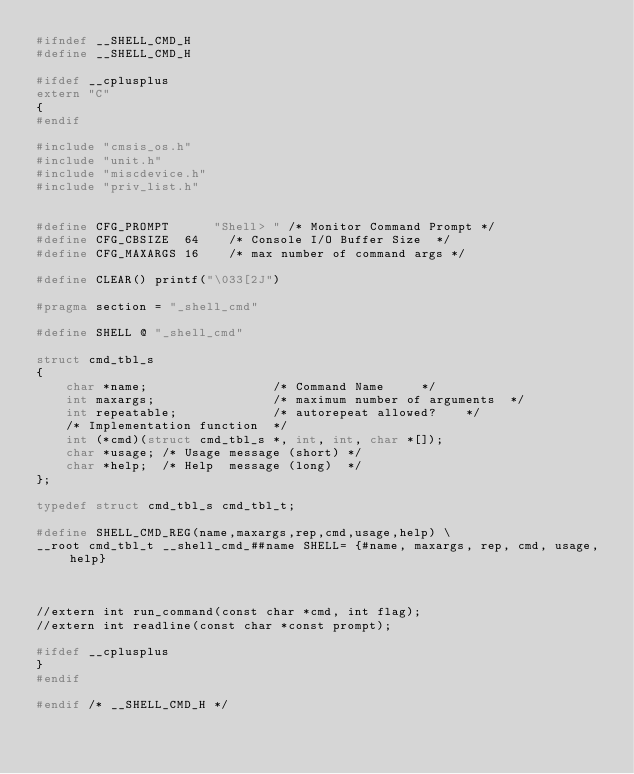Convert code to text. <code><loc_0><loc_0><loc_500><loc_500><_C_>#ifndef __SHELL_CMD_H
#define __SHELL_CMD_H

#ifdef __cplusplus
extern "C"
{
#endif

#include "cmsis_os.h"
#include "unit.h"
#include "miscdevice.h"
#include "priv_list.h"


#define	CFG_PROMPT			"Shell> "	/* Monitor Command Prompt	*/
#define CFG_CBSIZE	64		/* Console I/O Buffer Size	*/
#define	CFG_MAXARGS	16		/* max number of command args	*/

#define CLEAR() printf("\033[2J") 
  
#pragma section = "_shell_cmd"

#define SHELL @ "_shell_cmd"

struct cmd_tbl_s
{
    char *name;                 /* Command Name			*/
    int maxargs;                /* maximum number of arguments	*/
    int repeatable;             /* autorepeat allowed?		*/
    /* Implementation function	*/
    int (*cmd)(struct cmd_tbl_s *, int, int, char *[]);
    char *usage; /* Usage message	(short)	*/
    char *help;  /* Help  message	(long)	*/
};

typedef struct cmd_tbl_s cmd_tbl_t;

#define SHELL_CMD_REG(name,maxargs,rep,cmd,usage,help) \
__root cmd_tbl_t __shell_cmd_##name SHELL= {#name, maxargs, rep, cmd, usage, help}



//extern int run_command(const char *cmd, int flag);
//extern int readline(const char *const prompt);

#ifdef __cplusplus
}
#endif

#endif /* __SHELL_CMD_H */
</code> 